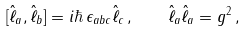Convert formula to latex. <formula><loc_0><loc_0><loc_500><loc_500>[ \hat { \ell } _ { a } , \hat { \ell } _ { b } ] = i \hbar { \, } \epsilon _ { a b c } \hat { \ell } _ { c } \, , \quad \hat { \ell } _ { a } \hat { \ell } _ { a } = g ^ { 2 } \, ,</formula> 